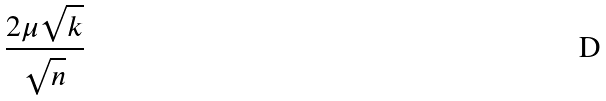<formula> <loc_0><loc_0><loc_500><loc_500>\frac { 2 \mu \sqrt { k } } { \sqrt { n } }</formula> 